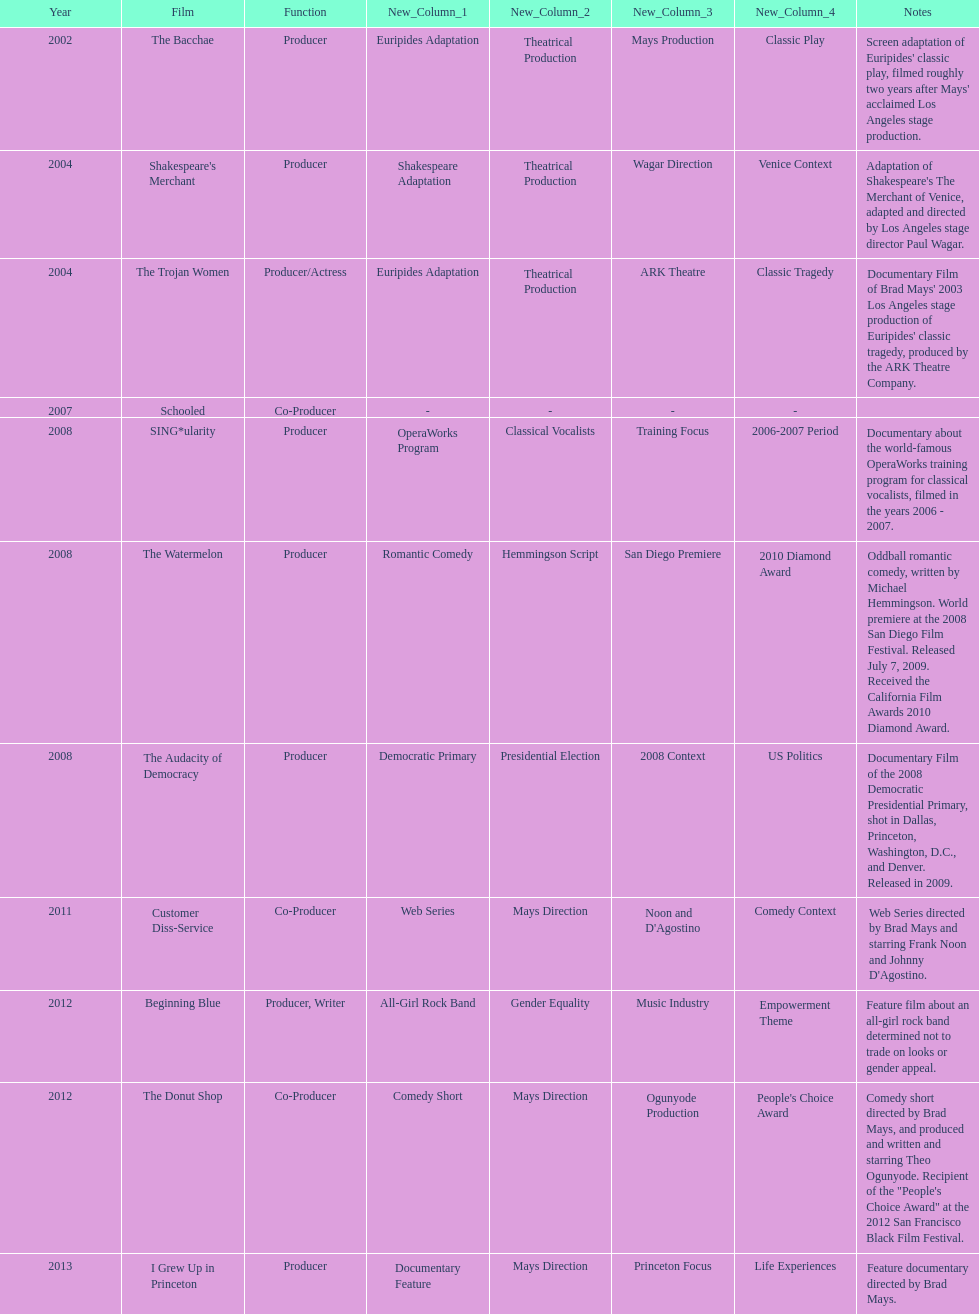Could you help me parse every detail presented in this table? {'header': ['Year', 'Film', 'Function', 'New_Column_1', 'New_Column_2', 'New_Column_3', 'New_Column_4', 'Notes'], 'rows': [['2002', 'The Bacchae', 'Producer', 'Euripides Adaptation', 'Theatrical Production', 'Mays Production', 'Classic Play', "Screen adaptation of Euripides' classic play, filmed roughly two years after Mays' acclaimed Los Angeles stage production."], ['2004', "Shakespeare's Merchant", 'Producer', 'Shakespeare Adaptation', 'Theatrical Production', 'Wagar Direction', 'Venice Context', "Adaptation of Shakespeare's The Merchant of Venice, adapted and directed by Los Angeles stage director Paul Wagar."], ['2004', 'The Trojan Women', 'Producer/Actress', 'Euripides Adaptation', 'Theatrical Production', 'ARK Theatre', 'Classic Tragedy', "Documentary Film of Brad Mays' 2003 Los Angeles stage production of Euripides' classic tragedy, produced by the ARK Theatre Company."], ['2007', 'Schooled', 'Co-Producer', '-', '-', '-', '-', ''], ['2008', 'SING*ularity', 'Producer', 'OperaWorks Program', 'Classical Vocalists', 'Training Focus', '2006-2007 Period', 'Documentary about the world-famous OperaWorks training program for classical vocalists, filmed in the years 2006 - 2007.'], ['2008', 'The Watermelon', 'Producer', 'Romantic Comedy', 'Hemmingson Script', 'San Diego Premiere', '2010 Diamond Award', 'Oddball romantic comedy, written by Michael Hemmingson. World premiere at the 2008 San Diego Film Festival. Released July 7, 2009. Received the California Film Awards 2010 Diamond Award.'], ['2008', 'The Audacity of Democracy', 'Producer', 'Democratic Primary', 'Presidential Election', '2008 Context', 'US Politics', 'Documentary Film of the 2008 Democratic Presidential Primary, shot in Dallas, Princeton, Washington, D.C., and Denver. Released in 2009.'], ['2011', 'Customer Diss-Service', 'Co-Producer', 'Web Series', 'Mays Direction', "Noon and D'Agostino", 'Comedy Context', "Web Series directed by Brad Mays and starring Frank Noon and Johnny D'Agostino."], ['2012', 'Beginning Blue', 'Producer, Writer', 'All-Girl Rock Band', 'Gender Equality', 'Music Industry', 'Empowerment Theme', 'Feature film about an all-girl rock band determined not to trade on looks or gender appeal.'], ['2012', 'The Donut Shop', 'Co-Producer', 'Comedy Short', 'Mays Direction', 'Ogunyode Production', "People's Choice Award", 'Comedy short directed by Brad Mays, and produced and written and starring Theo Ogunyode. Recipient of the "People\'s Choice Award" at the 2012 San Francisco Black Film Festival.'], ['2013', 'I Grew Up in Princeton', 'Producer', 'Documentary Feature', 'Mays Direction', 'Princeton Focus', 'Life Experiences', 'Feature documentary directed by Brad Mays.']]} Who was the first producer that made the film sing*ularity? Lorenda Starfelt. 